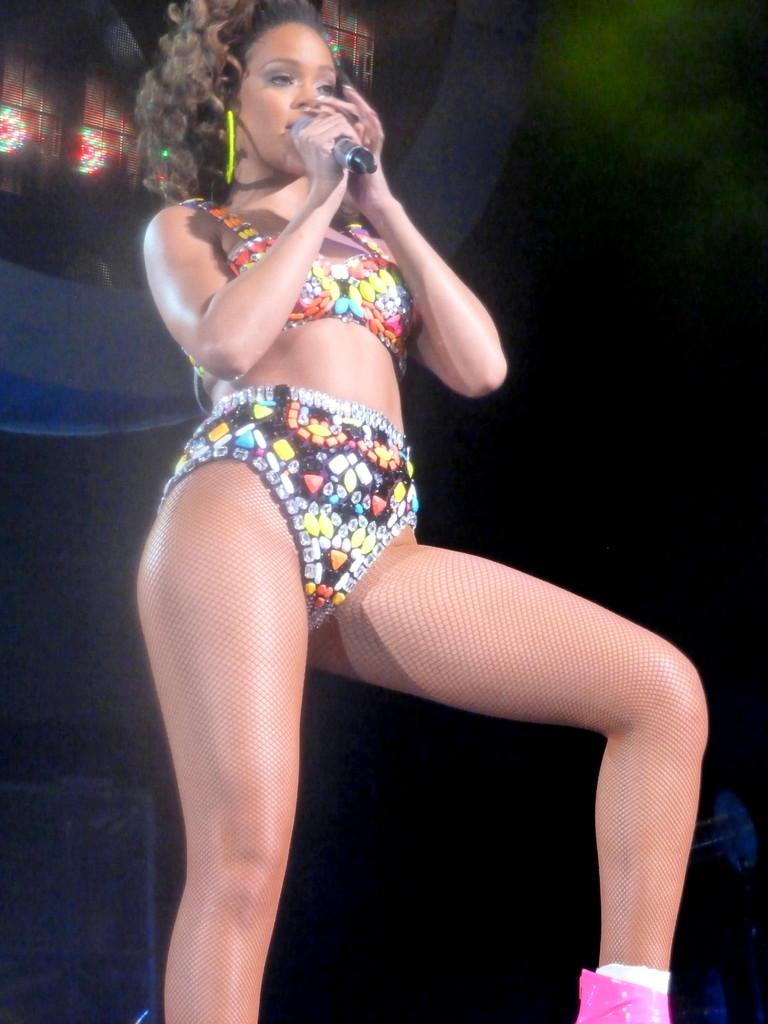Who is the main subject in the image? There is a woman in the image. What is the woman wearing? The woman is wearing a dress. What is the woman holding in the image? The woman is holding a microphone. What can be seen in the background of the image? There is a group of lights in the background of the image. What language is the woman speaking in the image? The image does not provide any information about the language being spoken, as there is no audio or text present. 